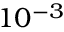<formula> <loc_0><loc_0><loc_500><loc_500>1 0 ^ { - 3 }</formula> 